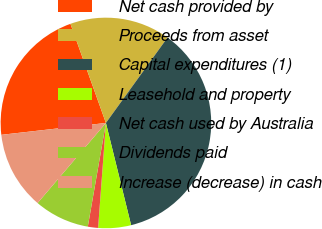Convert chart. <chart><loc_0><loc_0><loc_500><loc_500><pie_chart><fcel>Net cash provided by<fcel>Proceeds from asset<fcel>Capital expenditures (1)<fcel>Leasehold and property<fcel>Net cash used by Australia<fcel>Dividends paid<fcel>Increase (decrease) in cash<nl><fcel>21.33%<fcel>15.42%<fcel>36.21%<fcel>5.03%<fcel>1.57%<fcel>8.49%<fcel>11.96%<nl></chart> 